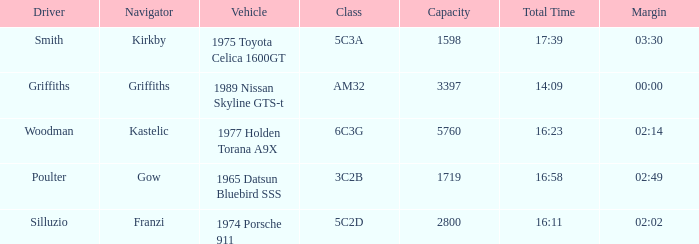What driver had a total time of 16:58? Poulter. 